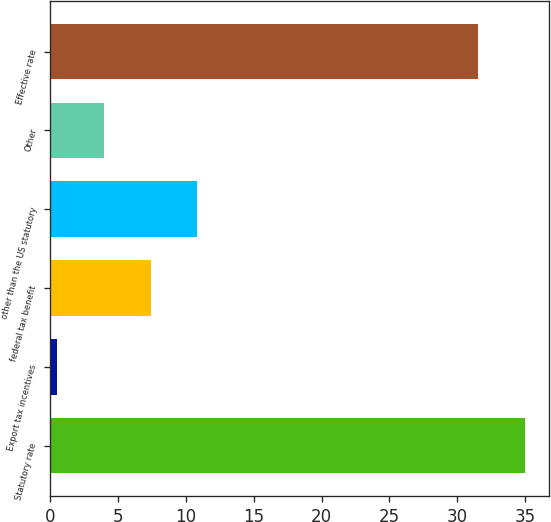Convert chart. <chart><loc_0><loc_0><loc_500><loc_500><bar_chart><fcel>Statutory rate<fcel>Export tax incentives<fcel>federal tax benefit<fcel>other than the US statutory<fcel>Other<fcel>Effective rate<nl><fcel>35<fcel>0.5<fcel>7.4<fcel>10.85<fcel>3.95<fcel>31.5<nl></chart> 